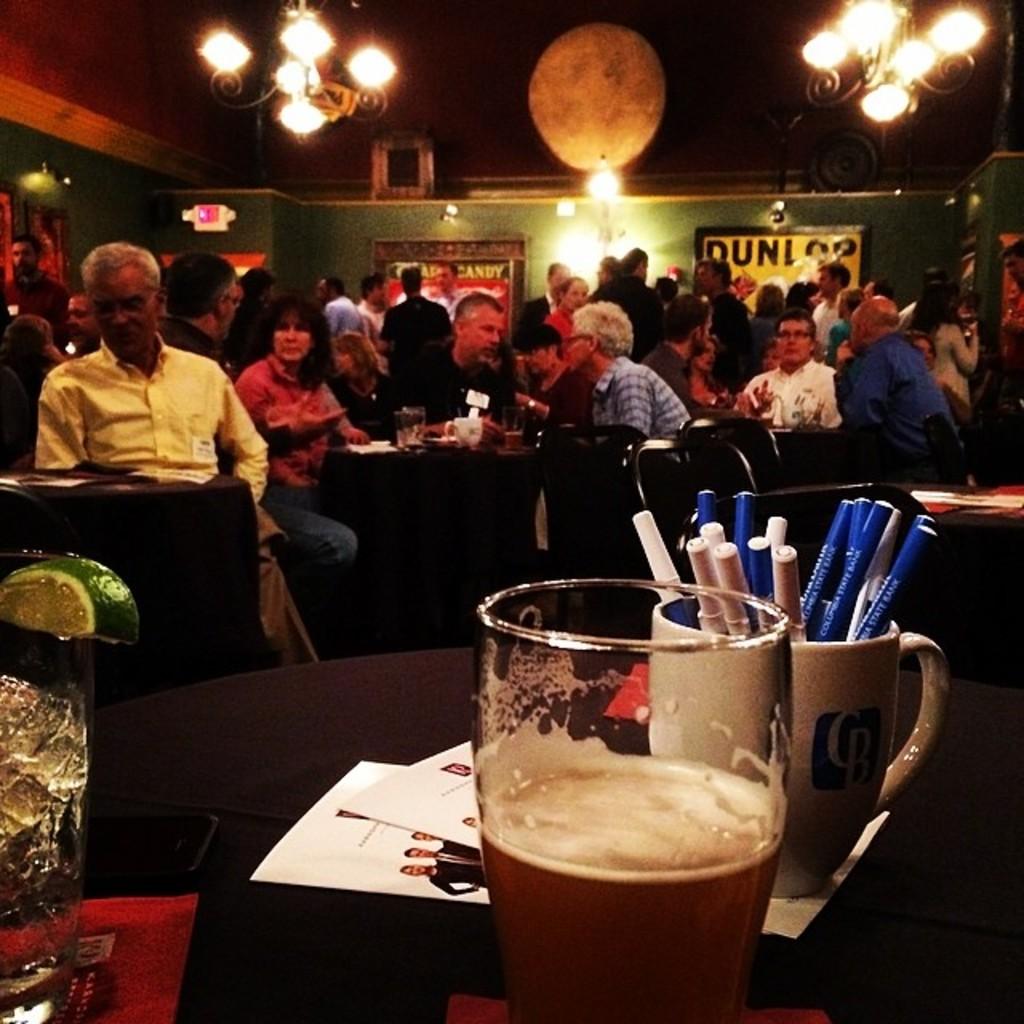What word is on the poster?
Your answer should be very brief. Dunlop. What is one of the letters seen on the yellow sign in the back?
Offer a terse response. U. 